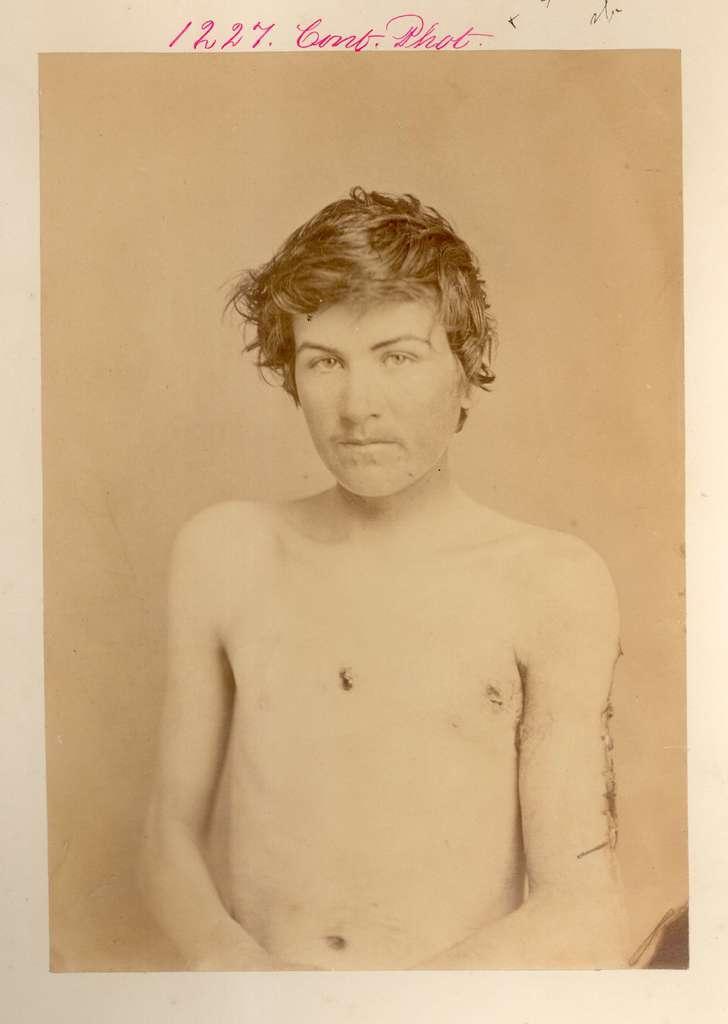Describe this image in one or two sentences. In this picture we can see poster. In the poster there is a man who is standing near to the wall. On the top we can see date. 